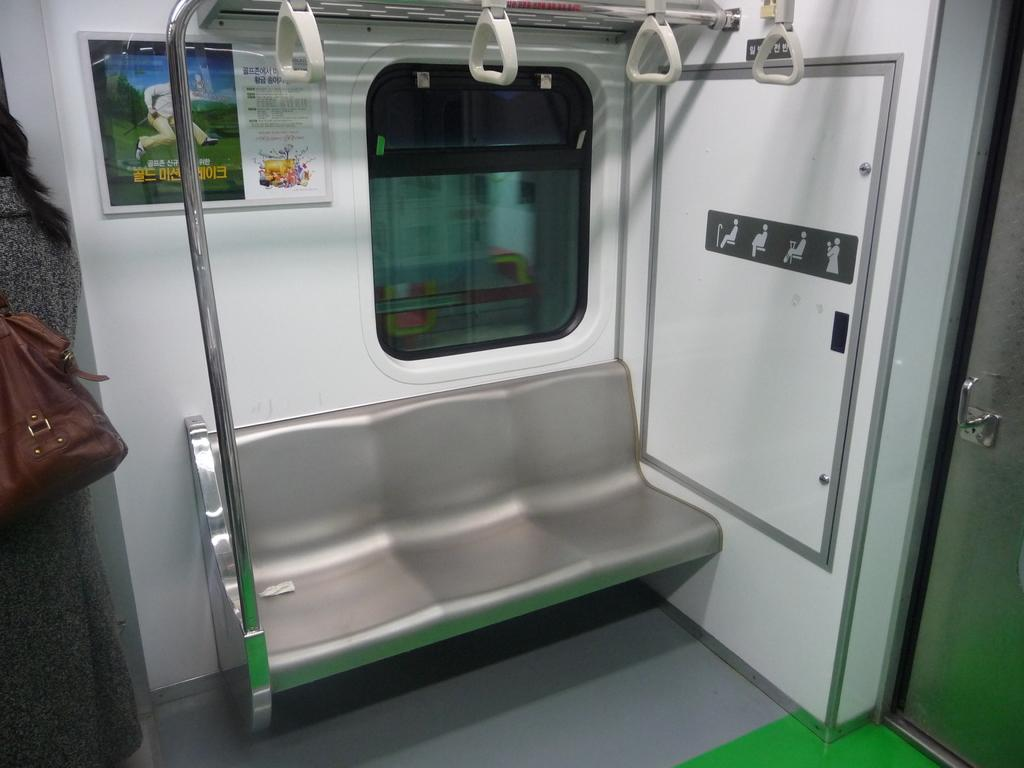What mode of transportation is the person in? The person is in a metro train. What type of seating is available in the train? There is a bench in the train. What is used to hang bags or coats in the train? There are hangers attached to a pole in the train. How can people enter or exit the train? There is a door in the train. What type of advertisement or information might be displayed in the train? There is a poster attached to the train. What type of cheese is being served on the hat in the image? There is no cheese or hat present in the image. 